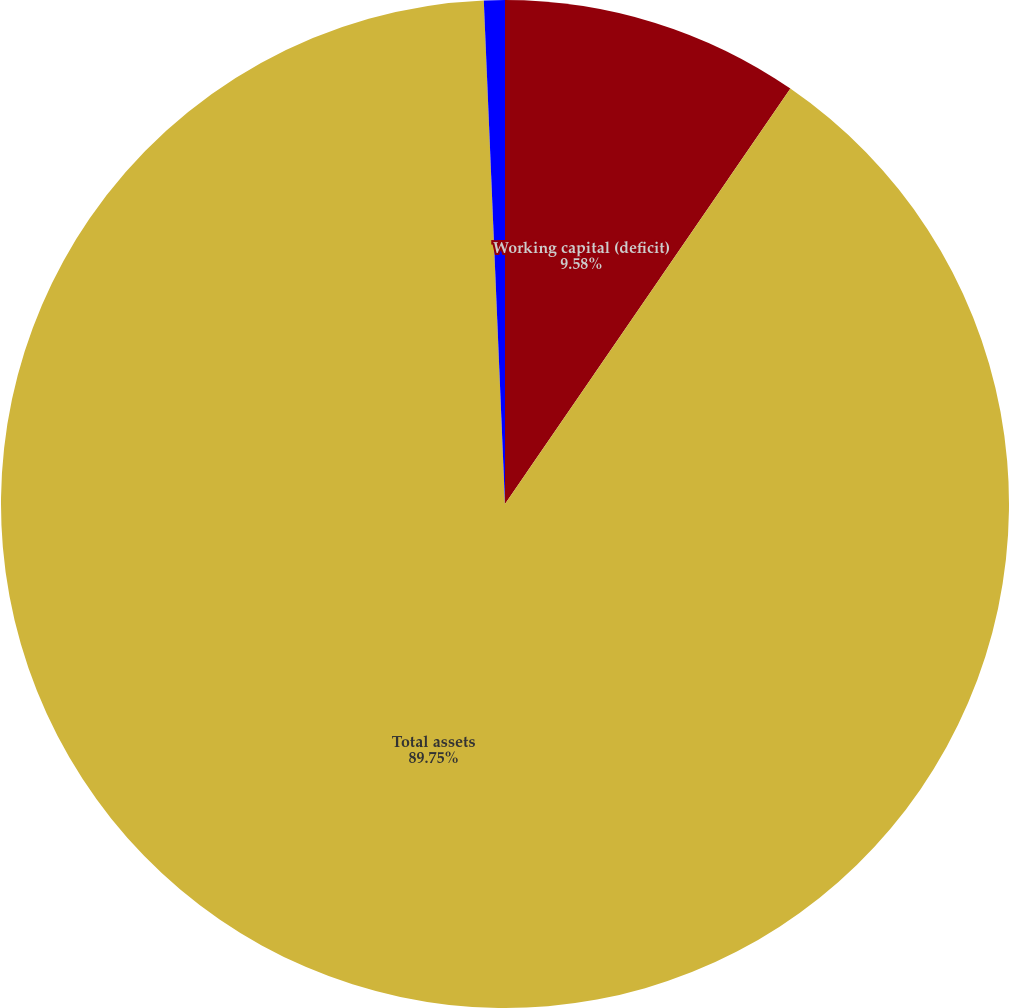<chart> <loc_0><loc_0><loc_500><loc_500><pie_chart><fcel>Working capital (deficit)<fcel>Total assets<fcel>Minority interest<nl><fcel>9.58%<fcel>89.75%<fcel>0.67%<nl></chart> 